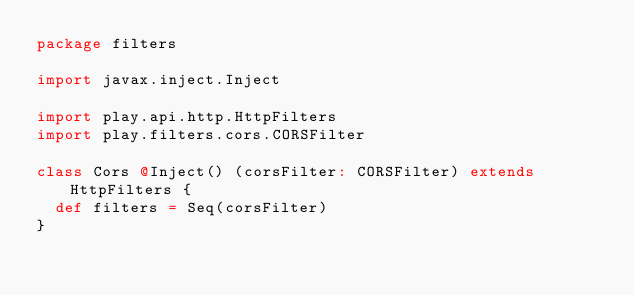Convert code to text. <code><loc_0><loc_0><loc_500><loc_500><_Scala_>package filters

import javax.inject.Inject

import play.api.http.HttpFilters
import play.filters.cors.CORSFilter

class Cors @Inject() (corsFilter: CORSFilter) extends HttpFilters {
  def filters = Seq(corsFilter)
}
</code> 